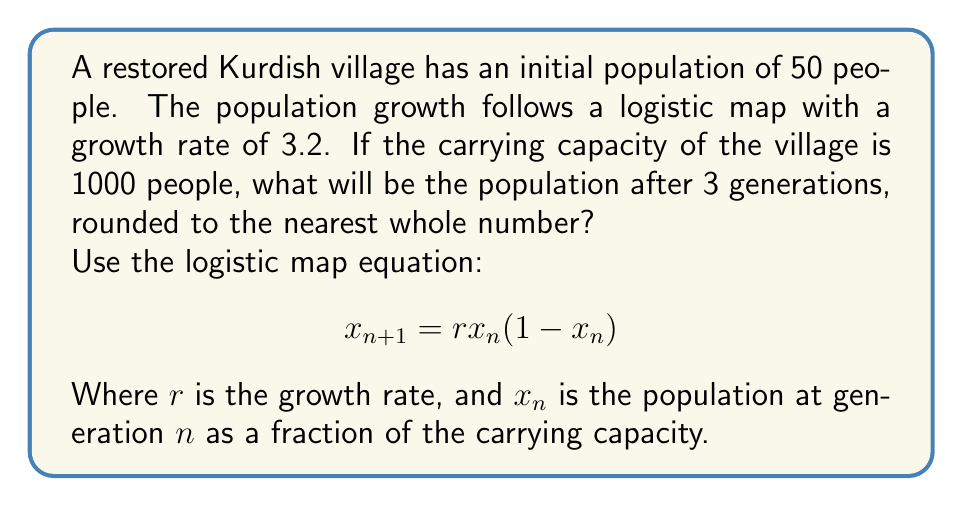Can you answer this question? 1. First, we need to calculate the initial population as a fraction of the carrying capacity:
   $x_0 = 50/1000 = 0.05$

2. Now, we'll use the logistic map equation to calculate the population for each generation:
   
   For generation 1:
   $x_1 = 3.2 * 0.05 * (1 - 0.05) = 0.152$

   For generation 2:
   $x_2 = 3.2 * 0.152 * (1 - 0.152) = 0.412928$

   For generation 3:
   $x_3 = 3.2 * 0.412928 * (1 - 0.412928) = 0.775999$

3. To get the actual population, we multiply the final result by the carrying capacity:
   $775.999 * 1000 = 775,999$

4. Rounding to the nearest whole number:
   $776$ people
Answer: 776 people 